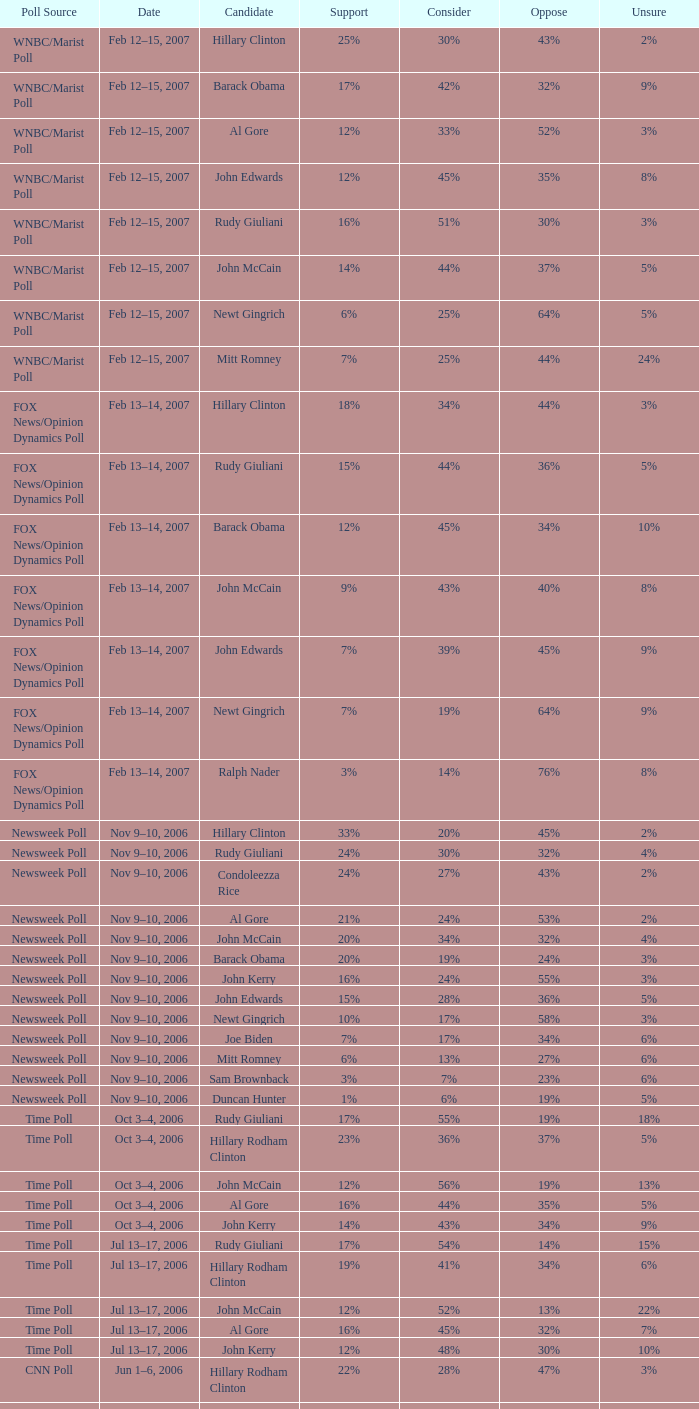What fraction of people were not in favor of the candidate based on the wnbc/marist poll that displayed 8% of individuals being undetermined? 35%. 